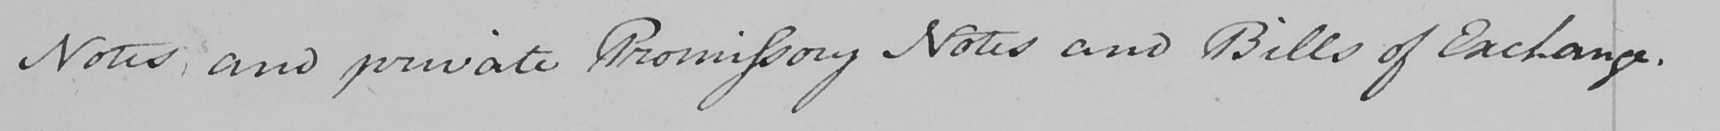Can you tell me what this handwritten text says? Notes ; and private Promissory Notes and Bills of Exchange . 